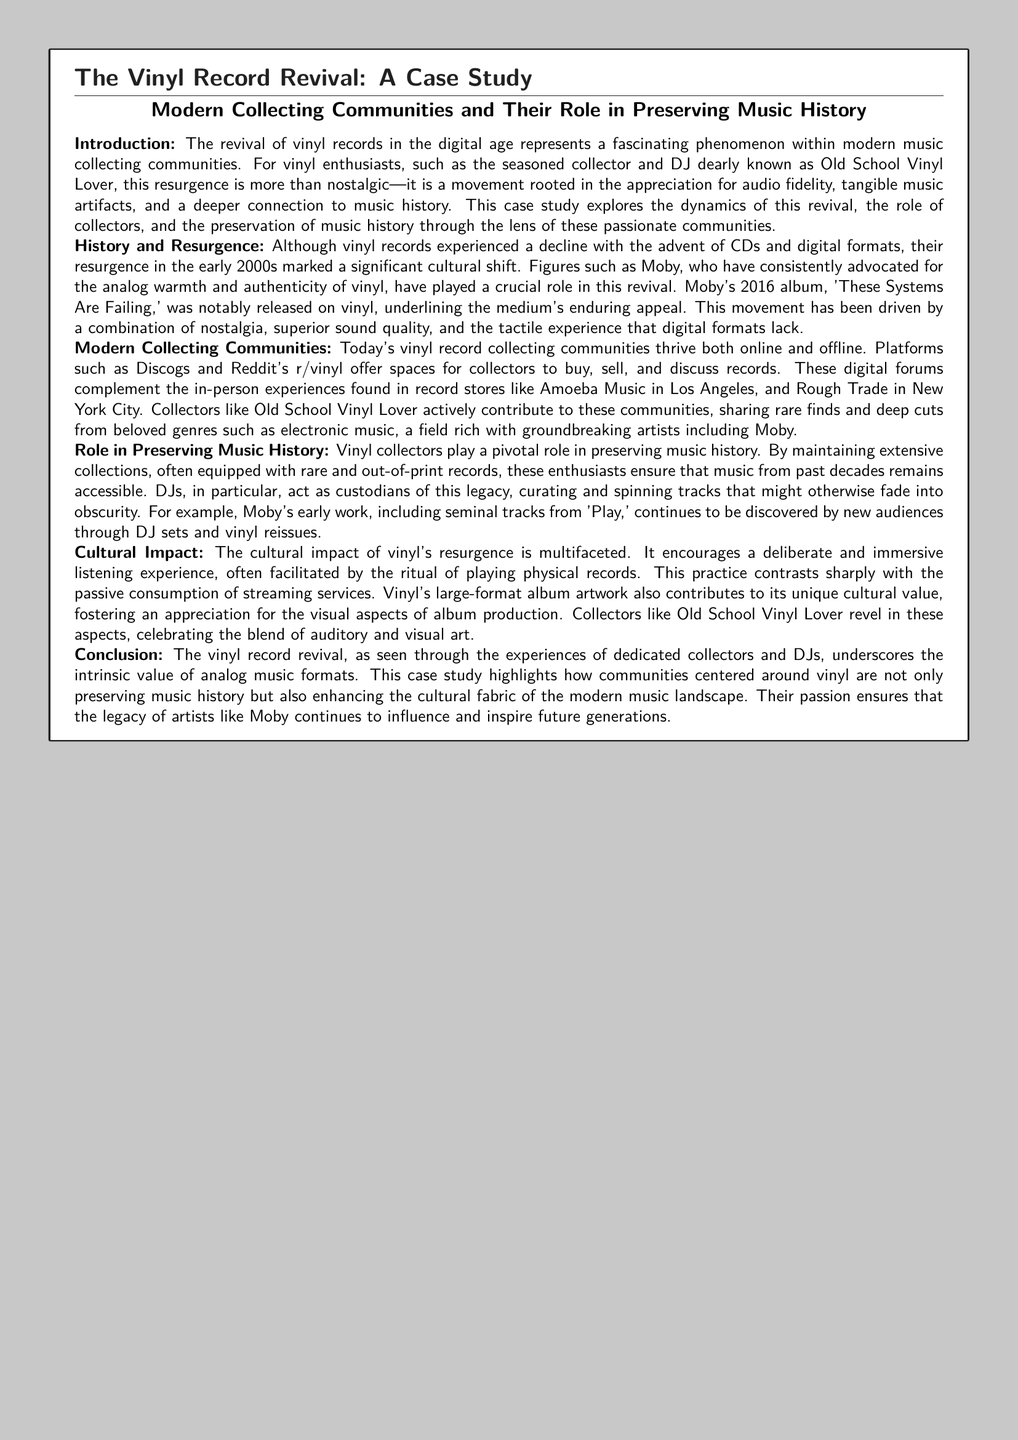What musical format experienced a decline with the advent of CDs? The document states that vinyl records experienced a decline with the advent of CDs and digital formats.
Answer: vinyl records Who is mentioned as advocating for the analog warmth of vinyl? The text specifies that Moby has consistently advocated for the analog warmth and authenticity of vinyl.
Answer: Moby What year was Moby's album 'These Systems Are Failing' released on vinyl? The document notes that Moby's album was released on vinyl in 2016.
Answer: 2016 What type of communities thrive both online and offline for vinyl collectors? The document mentions platforms such as Discogs and Reddit's r/vinyl as spaces for collectors.
Answer: collecting communities Which record store in Los Angeles is mentioned in the case study? The text refers to Amoeba Music in Los Angeles as a place for collectors.
Answer: Amoeba Music What experience does vinyl encourage compared to streaming services? The case study highlights that vinyl encourages a deliberate and immersive listening experience.
Answer: immersive listening experience What aspect of album production is celebrated by vinyl collectors according to the document? The document notes that vinyl's large-format album artwork contributes to its unique cultural value.
Answer: album artwork Who actively contributes to vinyl collecting communities by sharing rare finds? The document identifies Old School Vinyl Lover as someone who actively contributes to these communities.
Answer: Old School Vinyl Lover What role do DJs play in preserving music history? The case study indicates that DJs act as custodians of music legacy by curating and spinning tracks.
Answer: custodians 